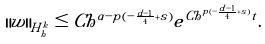<formula> <loc_0><loc_0><loc_500><loc_500>\| w \| _ { H ^ { k } _ { h } } \leq C h ^ { \alpha - p ( - \frac { d - 1 } 4 + s ) } e ^ { C h ^ { p ( - \frac { d - 1 } 4 + s ) } t } .</formula> 